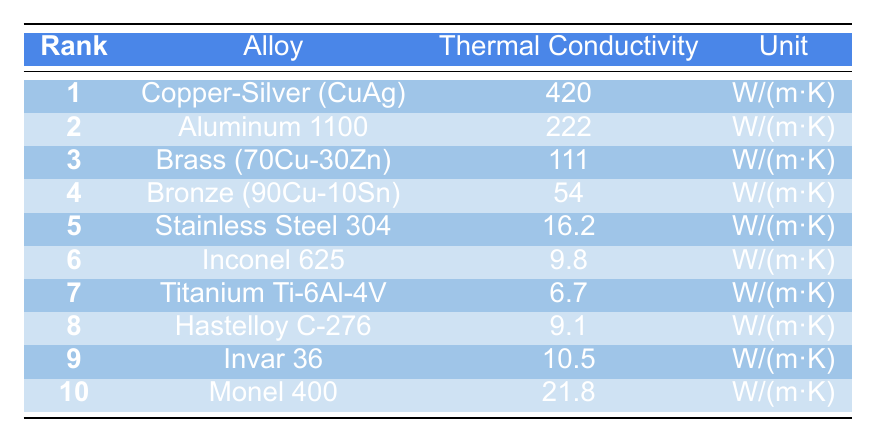What is the thermal conductivity of Copper-Silver (CuAg)? The table lists the thermal conductivity of Copper-Silver (CuAg) as 420 W/(m·K) in the respective row.
Answer: 420 W/(m·K) Which alloy ranks second for thermal conductivity? Looking at the rank column in the table, the second rank is assigned to Aluminum 1100.
Answer: Aluminum 1100 What is the thermal conductivity difference between Brass (70Cu-30Zn) and Bronze (90Cu-10Sn)? Brass (70Cu-30Zn) has a thermal conductivity of 111 W/(m·K) and Bronze (90Cu-10Sn) has 54 W/(m·K). The difference is 111 - 54 = 57 W/(m·K).
Answer: 57 W/(m·K) Is the thermal conductivity of Stainless Steel 304 greater than that of Inconel 625? Stainless Steel 304 has a thermal conductivity of 16.2 W/(m·K) and Inconel 625 has 9.8 W/(m·K). Since 16.2 > 9.8, the statement is true.
Answer: Yes What is the average thermal conductivity of the alloys ranked 1 through 5? To find the average, we first sum the thermal conductivities of the top five alloys: 420 + 222 + 111 + 54 + 16.2 = 823.2 W/(m·K). Then divide by 5: 823.2 / 5 = 164.64 W/(m·K).
Answer: 164.64 W/(m·K) Which alloy has the lowest thermal conductivity among the listed alloys? By examining the table, Titanium Ti-6Al-4V has the lowest thermal conductivity at 6.7 W/(m·K).
Answer: Titanium Ti-6Al-4V How does the thermal conductivity of Monel 400 compare to that of Hastelloy C-276? Monel 400 has a thermal conductivity of 21.8 W/(m·K) and Hastelloy C-276 has 9.1 W/(m·K). Since 21.8 is greater than 9.1, Monel 400 has higher conductivity.
Answer: Higher If you were to remove the top three alloys by thermal conductivity, what would be the thermal conductivity of the next highest? After removing Copper-Silver (CuAg), Aluminum 1100, and Brass (70Cu-30Zn), the next alloy is Bronze (90Cu-10Sn) with a thermal conductivity of 54 W/(m·K).
Answer: 54 W/(m·K) What is the total thermal conductivity of the alloys ranked from 1 to 4? We sum the thermal conductivities of the top four alloys: 420 + 222 + 111 + 54 = 807 W/(m·K).
Answer: 807 W/(m·K) Does any alloy have a thermal conductivity greater than 400 W/(m·K)? Looking at the table, only Copper-Silver (CuAg) has a thermal conductivity of 420 W/(m·K), which is greater than 400.
Answer: Yes 